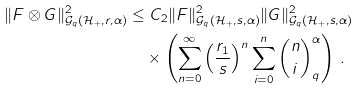Convert formula to latex. <formula><loc_0><loc_0><loc_500><loc_500>\| F \otimes G \| ^ { 2 } _ { \mathcal { G } _ { q } ( \mathcal { H } _ { + } , r , \alpha ) } & \leq C _ { 2 } \| F \| ^ { 2 } _ { \mathcal { G } _ { q } ( \mathcal { H } _ { + } , s , \alpha ) } \| G \| ^ { 2 } _ { \mathcal { G } _ { q } ( \mathcal { H } _ { + } , s , \alpha ) } \\ & \quad \times \left ( \sum _ { n = 0 } ^ { \infty } \left ( \frac { r _ { 1 } } s \right ) ^ { n } \sum _ { i = 0 } ^ { n } { n \choose i } _ { q } ^ { \alpha } \right ) \, .</formula> 